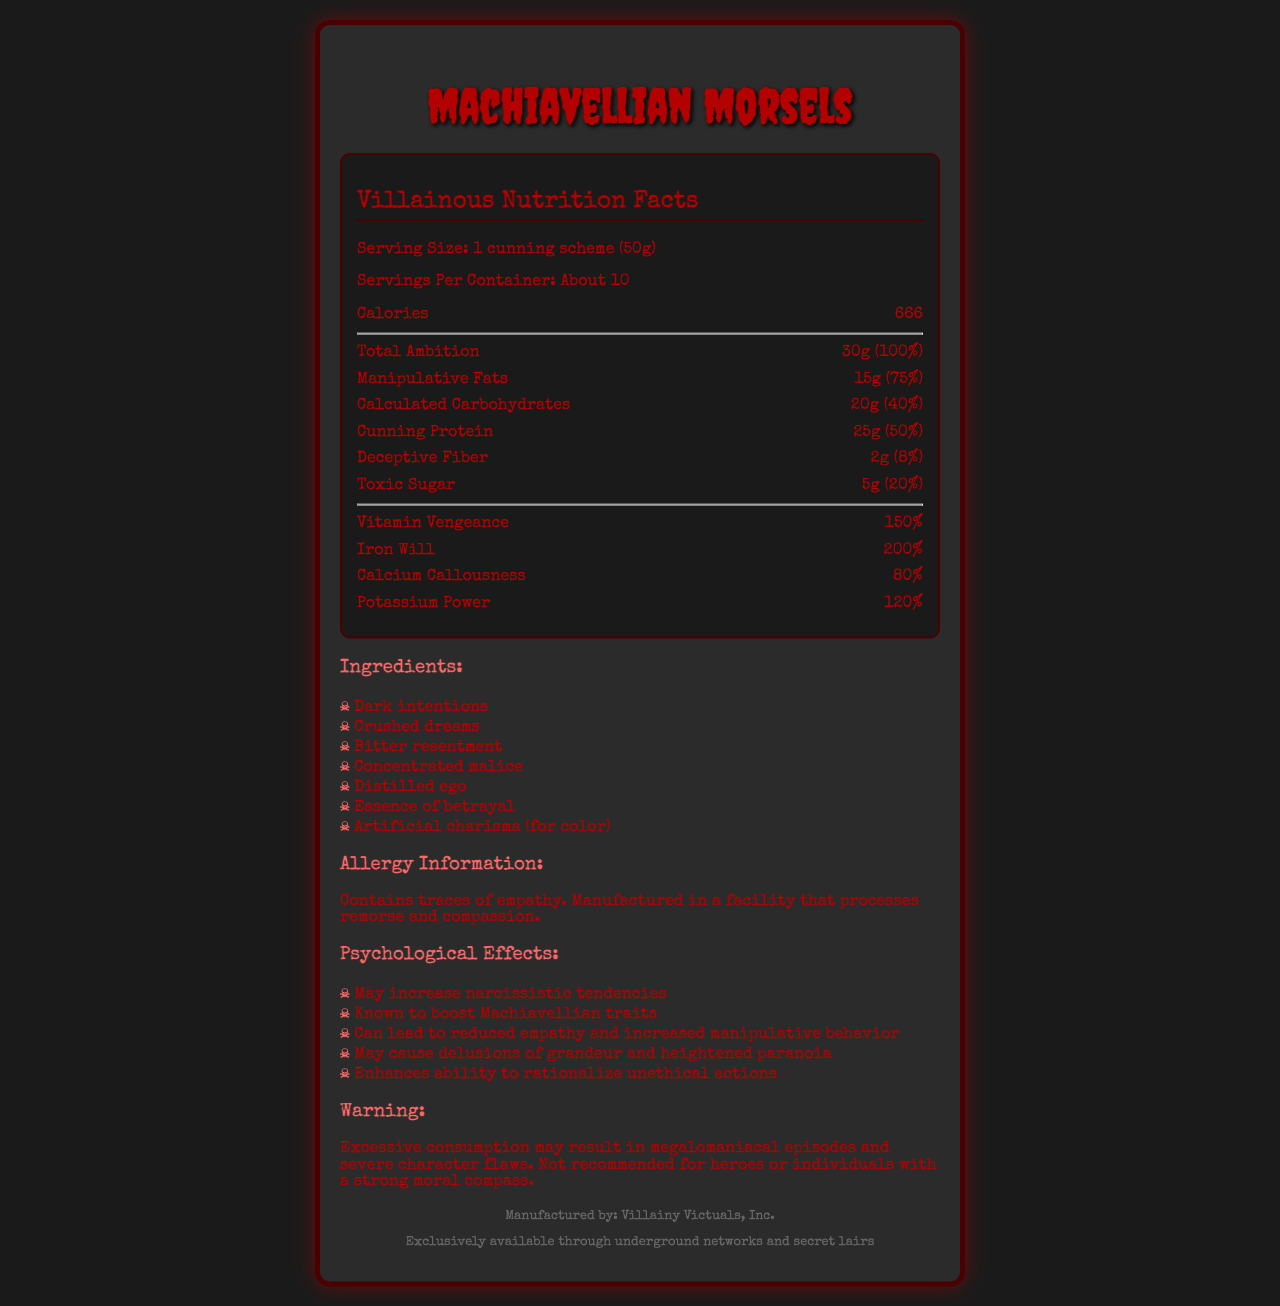what is the serving size? The serving size is listed as "1 cunning scheme (50g)" in the document.
Answer: 1 cunning scheme (50g) how many calories are in one serving? The document states that one serving contains 666 calories.
Answer: 666 what is the percentage of daily value for Total Ambition? The daily value for Total Ambition is given as 100%.
Answer: 100% what are the psychological effects of consuming this product? The psychological effects are listed under a section specifically for them in the document.
Answer: May increase narcissistic tendencies, Known to boost Machiavellian traits, Can lead to reduced empathy and increased manipulative behavior, May cause delusions of grandeur and heightened paranoia, Enhances ability to rationalize unethical actions which ingredient gives color to the product? The document lists "Artificial charisma (for color)" among the ingredients.
Answer: Artificial charisma what is the warning associated with the consumption of this product? The warning section explicitly states the potential risks and who should avoid the product.
Answer: Excessive consumption may result in megalomaniacal episodes and severe character flaws. Not recommended for heroes or individuals with a strong moral compass. what vitamins and minerals are included in the product? A. Vitamin Vengeance, Iron Will, Calcium Callousness B. Vitamin Compassion, Iron Will, Calcium Callousness C. Vitamin Vengeance, Iron Will, Calcium Callousness, Potassium Power The vitamins and minerals included in the product are Vitamin Vengeance, Iron Will, Calcium Callousness, and Potassium Power, as listed in the document.
Answer: C what is the source of bitterness in the ingredients? A. Dark intentions B. Crushed dreams C. Bitter resentment According to the ingredients list, "Bitter resentment" is the source of bitterness.
Answer: C does the product contain empathy? The document mentions that the product contains traces of empathy.
Answer: Yes summarize the main idea of the document. The document outlines various aspects of Machiavellian Morsels, including serving size, caloric content, nutritional values, ingredients, potential psychological effects, and warnings, characterizing it as a product suitable for villains rather than heroes or morally upright individuals.
Answer: The document provides detailed nutritional information about a fictional villain-themed food product called Machiavellian Morsels, focusing on its unique ingredients, psychological effects, and specific warnings suitable for a villainous consumer. describe the distribution method for this product. The distribution section states that the product is exclusively available through underground networks and secret lairs.
Answer: Exclusively available through underground networks and secret lairs how much Cunning Protein is in a single serving? The nutrient list shows that there is 25g of Cunning Protein per serving.
Answer: 25g who manufactures Machiavellian Morsels? The footer of the document specifies the manufacturer as Villainy Victuals, Inc.
Answer: Villainy Victuals, Inc. what is the daily value percentage of Iron Will? The daily value percentage for Iron Will is given as 200% in the document.
Answer: 200% what kind of facility processes this product? The allergy information states that the product is manufactured in a facility that processes remorse and compassion.
Answer: A facility that processes remorse and compassion what are some of the ingredients in Machiavellian Morsels? The ingredients section lists these specific components.
Answer: Dark intentions, Crushed dreams, Bitter resentment, Concentrated malice, Distilled ego, Essence of betrayal, Artificial charisma (for color) what are Calculated Carbohydrates? A. 15g B. 20g C. 25g The nutrient list provides that Calculated Carbohydrates amount to 20g per serving.
Answer: B what is the theme or design style of the document? The document is designed to reflect a spooky and villainous theme as evident from the choice of fonts, colors, and overall layout.
Answer: The document has a dark and villainous theme with stylized fonts and colors, such as red and black, fitting a sinister and menacing aesthetic. how many servings are in one container of Machiavellian Morsels? The document specifies that there are about 10 servings per container.
Answer: About 10 what are some properties enhanced by consuming Machiavellian Morsels? The psychological effects section of the document lists these properties.
Answer: May increase narcissistic tendencies, Known to boost Machiavellian traits, Can lead to reduced empathy and increased manipulative behavior, May cause delusions of grandeur and heightened paranoia, Enhances ability to rationalize unethical actions what is the cost of Machiavellian Morsels? The document does not provide any information about the cost of Machiavellian Morsels.
Answer: Cannot be determined 